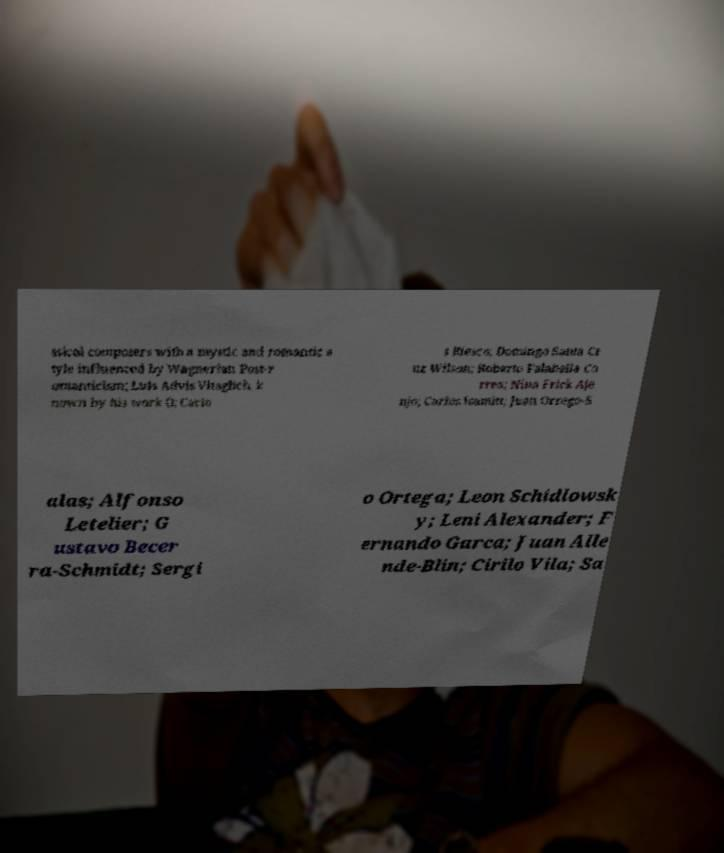Please identify and transcribe the text found in this image. ssical composers with a mystic and romantic s tyle influenced by Wagnerian Post-r omanticism; Luis Advis Vitaglich, k nown by his work (); Carlo s Riesco; Domingo Santa Cr uz Wilson; Roberto Falabella Co rrea; Nina Frick Aje njo; Carlos Isamitt; Juan Orrego-S alas; Alfonso Letelier; G ustavo Becer ra-Schmidt; Sergi o Ortega; Leon Schidlowsk y; Leni Alexander; F ernando Garca; Juan Alle nde-Blin; Cirilo Vila; Sa 